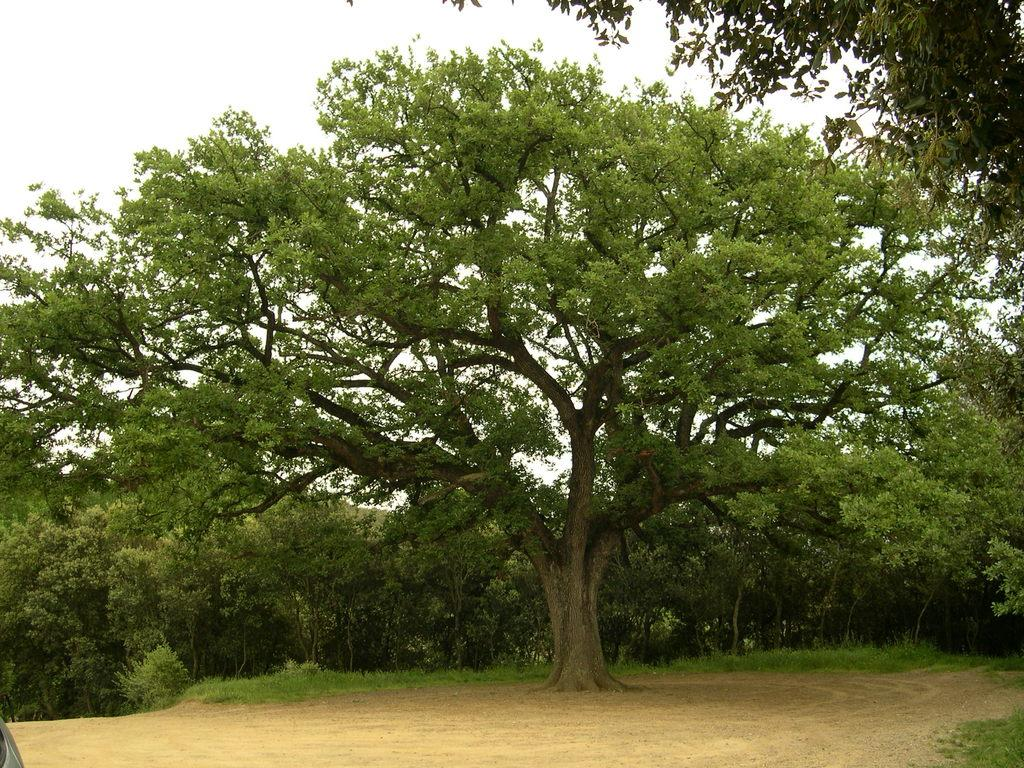What type of surface can be seen in the image? There is ground visible in the image. What natural elements are present in the image? There are trees in the image. What colors are the trees in the image? The trees are green and brown in color. What is visible in the background of the image? The sky is visible in the background of the image. How many nuts are hanging from the trees in the image? There are no nuts visible in the image; only trees are present. What idea is being conveyed by the trees in the image? The image does not convey any specific idea; it simply depicts trees and the ground. 